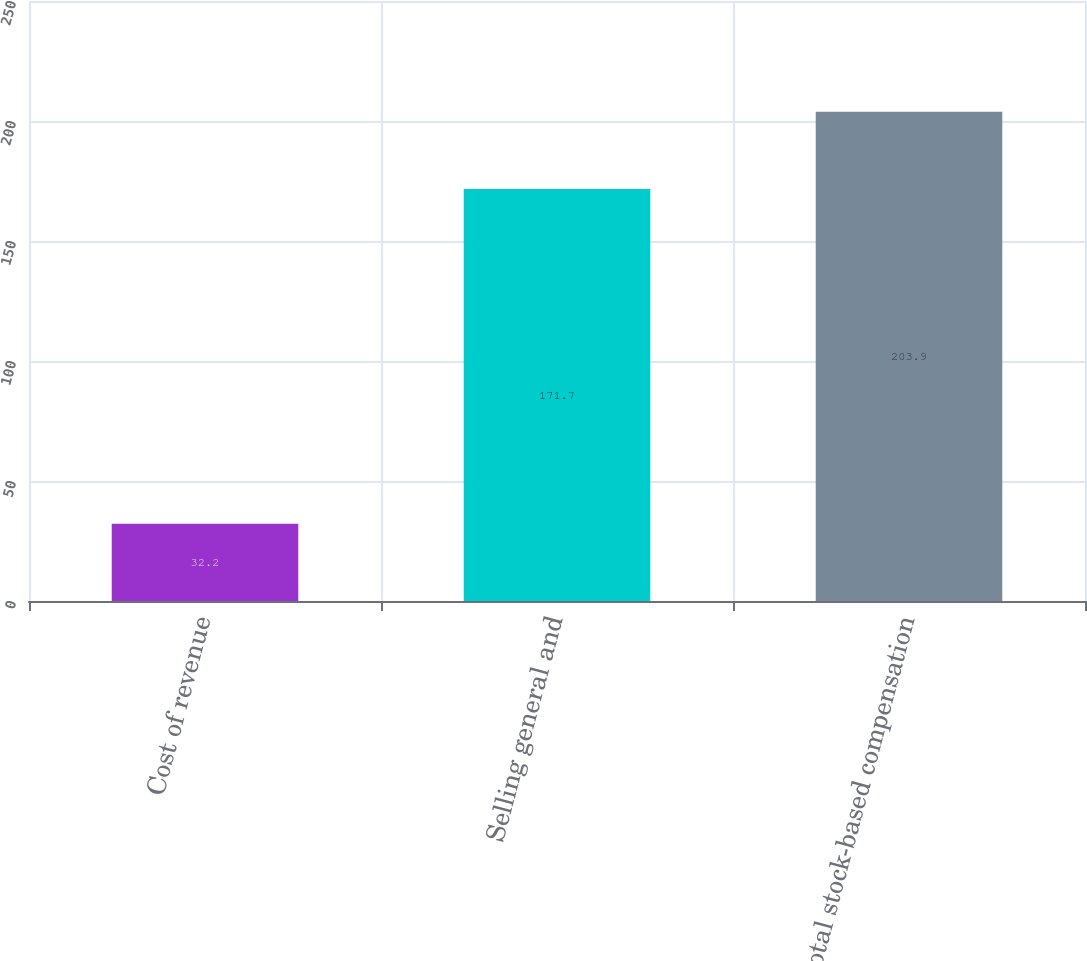Convert chart. <chart><loc_0><loc_0><loc_500><loc_500><bar_chart><fcel>Cost of revenue<fcel>Selling general and<fcel>Total stock-based compensation<nl><fcel>32.2<fcel>171.7<fcel>203.9<nl></chart> 